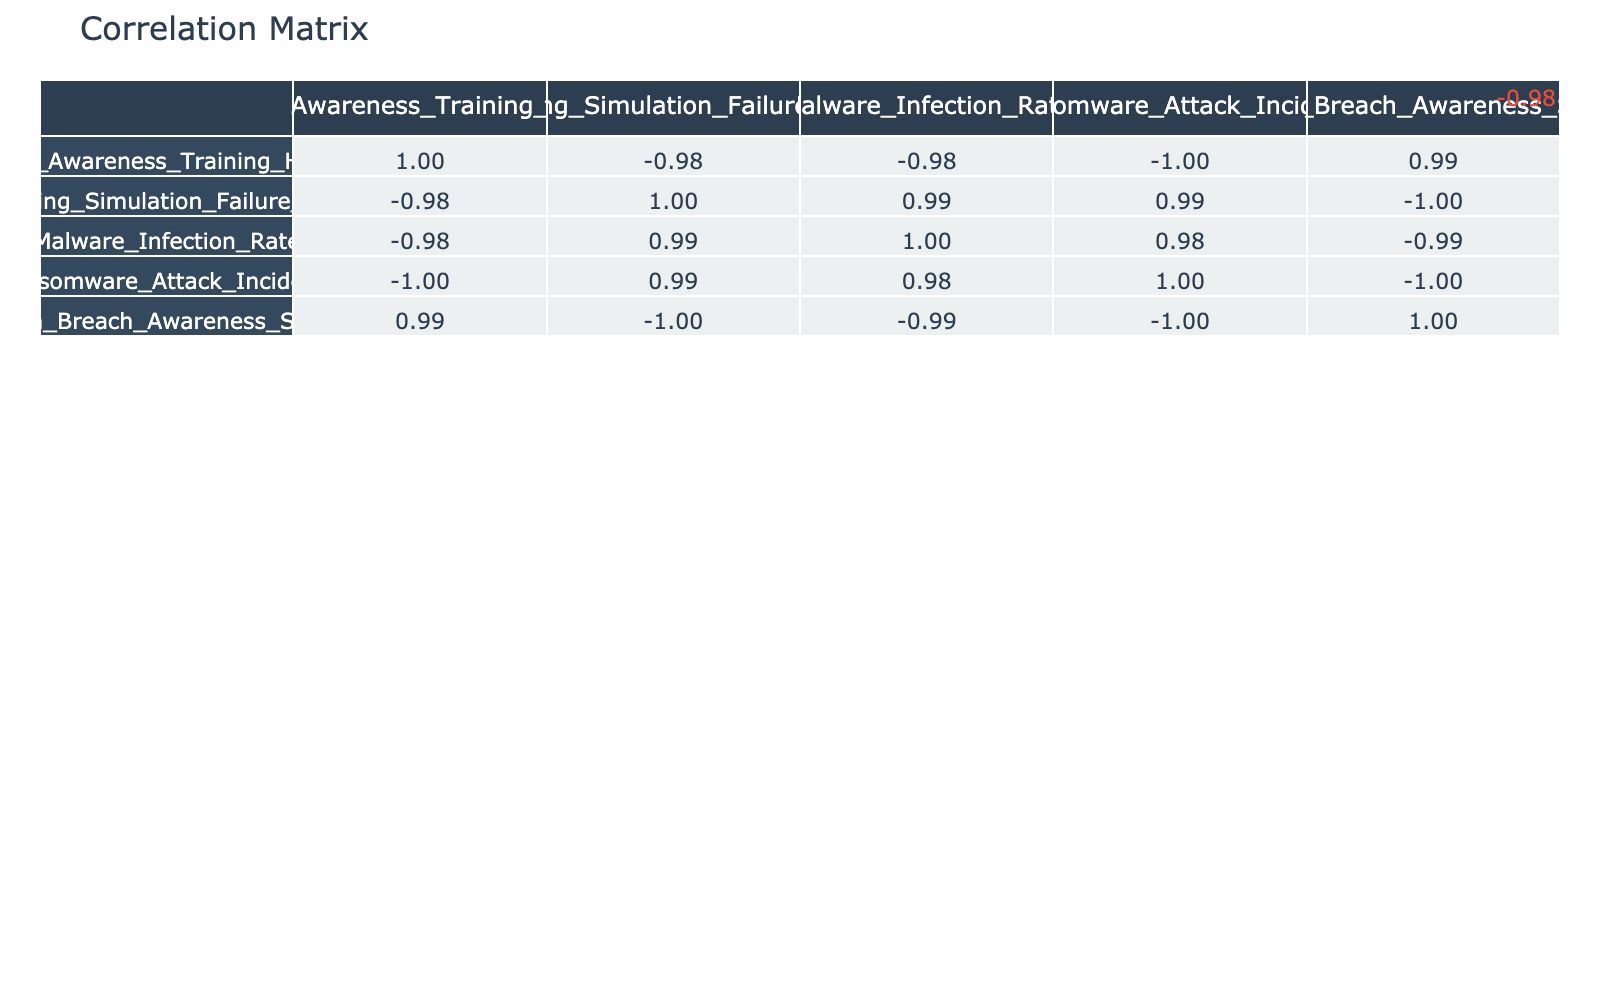What is the correlation between user awareness training hours and the phishing simulation failure rate? The correlation value between these two variables can be found in the table. Referring to the table, the correlation coefficient is -0.94, indicating a strong negative correlation, meaning that as user awareness training hours increase, the phishing simulation failure rate decreases.
Answer: -0.94 How many ransomware attack incidents occurred when user awareness training hours were at 20? From the table, when user awareness training hours were 20, the ransomware attack incidents recorded is 1.
Answer: 1 What is the average malware infection rate across all levels of user awareness training? To calculate the average, sum the malware infection rates and divide by the number of data points. Adding the rates (30 + 20 + 15 + 10 + 5) equals 80. There are 5 data points, so the average is 80/5 = 16.
Answer: 16 Is there a positive correlation between data breach awareness score and user awareness training hours? In the table, the correlation value between data breach awareness score and user awareness training hours is 0.99, indicating a strong positive correlation, implying that as training hours increase, the awareness score also tends to increase.
Answer: Yes What is the difference in phishing simulation failure rates between 1 and 20 hours of user awareness training? The failure rate for 1 hour is 75, and for 20 hours, it is 15. The difference is calculated by subtracting the lower value (15) from the higher value (75), yielding 75 - 15 = 60.
Answer: 60 Which training hours had the least data breaches awareness score and what is that score? The table indicates that the least data breach awareness score occurred at 1 hour of training, and the score is 35. This is evident by comparing the scores across all training hour entries.
Answer: 35 How many points in the table result in a phishing simulation failure rate below 30? Upon reviewing the table, the entries with failure rates below 30 occur at 10 hours, 15 hours, and 20 hours. Therefore, there are 3 instances of this situation.
Answer: 3 What is the overall trend you observe regarding user awareness training hours and the ransomware attack incidents? Looking at the table, there is an inverse relationship; as user awareness training hours increase, the number of ransomware attack incidents decreases from 10 at 1 hour to just 1 at 20 hours, indicating that increased training leads to fewer incidents.
Answer: Decreasing What is the correlation between malware infection rate and phishing simulation failure rate? According to the table, the correlation coefficient between malware infection rate and phishing simulation failure rate is 0.95. This high positive correlation suggests that as the phishing simulation failure rate increases, the malware infection rate also tends to increase.
Answer: 0.95 